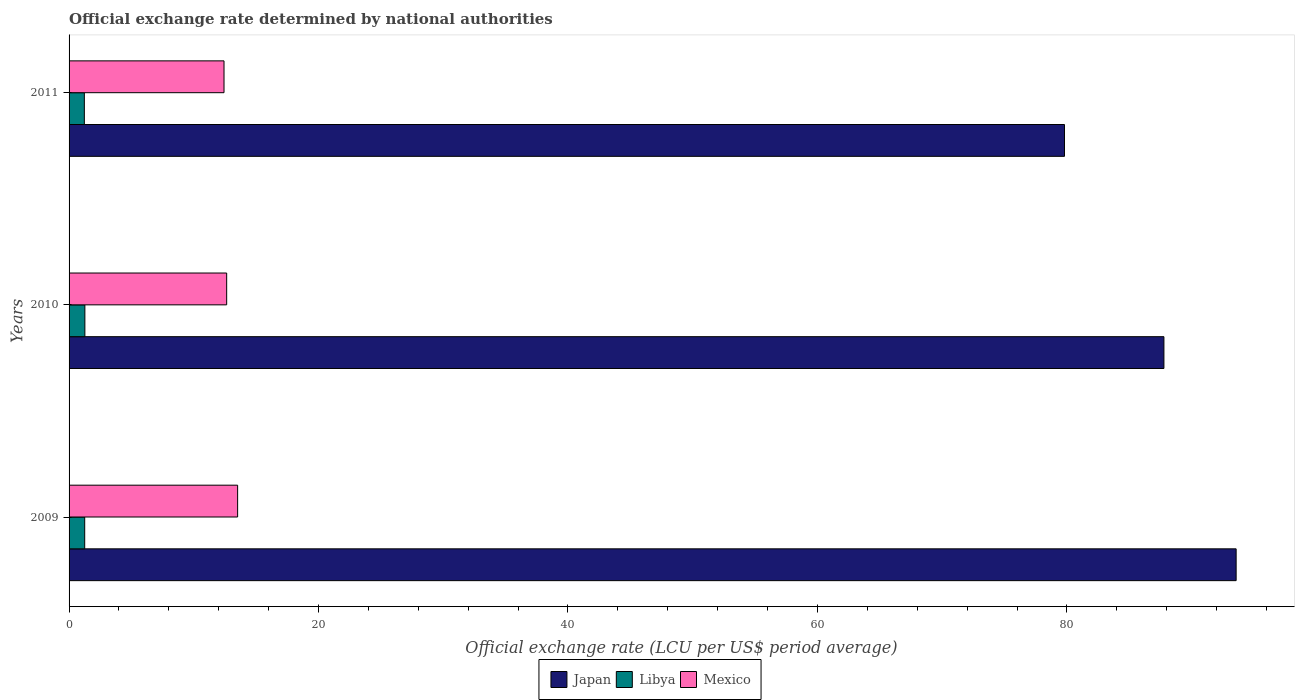Are the number of bars on each tick of the Y-axis equal?
Provide a short and direct response. Yes. How many bars are there on the 2nd tick from the top?
Provide a short and direct response. 3. How many bars are there on the 1st tick from the bottom?
Your response must be concise. 3. In how many cases, is the number of bars for a given year not equal to the number of legend labels?
Your answer should be very brief. 0. What is the official exchange rate in Libya in 2011?
Provide a succinct answer. 1.22. Across all years, what is the maximum official exchange rate in Libya?
Give a very brief answer. 1.27. Across all years, what is the minimum official exchange rate in Mexico?
Make the answer very short. 12.42. What is the total official exchange rate in Mexico in the graph?
Provide a succinct answer. 38.57. What is the difference between the official exchange rate in Mexico in 2010 and that in 2011?
Provide a short and direct response. 0.21. What is the difference between the official exchange rate in Libya in 2010 and the official exchange rate in Mexico in 2009?
Offer a very short reply. -12.25. What is the average official exchange rate in Mexico per year?
Give a very brief answer. 12.86. In the year 2010, what is the difference between the official exchange rate in Libya and official exchange rate in Japan?
Offer a very short reply. -86.51. In how many years, is the official exchange rate in Japan greater than 32 LCU?
Your answer should be very brief. 3. What is the ratio of the official exchange rate in Libya in 2009 to that in 2011?
Give a very brief answer. 1.02. What is the difference between the highest and the second highest official exchange rate in Libya?
Provide a succinct answer. 0.01. What is the difference between the highest and the lowest official exchange rate in Mexico?
Ensure brevity in your answer.  1.09. What does the 1st bar from the top in 2011 represents?
Keep it short and to the point. Mexico. What does the 3rd bar from the bottom in 2011 represents?
Give a very brief answer. Mexico. How many bars are there?
Provide a short and direct response. 9. What is the difference between two consecutive major ticks on the X-axis?
Offer a terse response. 20. Are the values on the major ticks of X-axis written in scientific E-notation?
Ensure brevity in your answer.  No. Does the graph contain any zero values?
Your answer should be compact. No. Does the graph contain grids?
Your answer should be compact. No. How are the legend labels stacked?
Keep it short and to the point. Horizontal. What is the title of the graph?
Offer a very short reply. Official exchange rate determined by national authorities. What is the label or title of the X-axis?
Make the answer very short. Official exchange rate (LCU per US$ period average). What is the Official exchange rate (LCU per US$ period average) in Japan in 2009?
Offer a very short reply. 93.57. What is the Official exchange rate (LCU per US$ period average) in Libya in 2009?
Keep it short and to the point. 1.25. What is the Official exchange rate (LCU per US$ period average) of Mexico in 2009?
Keep it short and to the point. 13.51. What is the Official exchange rate (LCU per US$ period average) of Japan in 2010?
Ensure brevity in your answer.  87.78. What is the Official exchange rate (LCU per US$ period average) of Libya in 2010?
Offer a very short reply. 1.27. What is the Official exchange rate (LCU per US$ period average) of Mexico in 2010?
Keep it short and to the point. 12.64. What is the Official exchange rate (LCU per US$ period average) in Japan in 2011?
Keep it short and to the point. 79.81. What is the Official exchange rate (LCU per US$ period average) of Libya in 2011?
Make the answer very short. 1.22. What is the Official exchange rate (LCU per US$ period average) in Mexico in 2011?
Keep it short and to the point. 12.42. Across all years, what is the maximum Official exchange rate (LCU per US$ period average) of Japan?
Your answer should be very brief. 93.57. Across all years, what is the maximum Official exchange rate (LCU per US$ period average) of Libya?
Offer a very short reply. 1.27. Across all years, what is the maximum Official exchange rate (LCU per US$ period average) of Mexico?
Offer a terse response. 13.51. Across all years, what is the minimum Official exchange rate (LCU per US$ period average) in Japan?
Your answer should be very brief. 79.81. Across all years, what is the minimum Official exchange rate (LCU per US$ period average) of Libya?
Provide a succinct answer. 1.22. Across all years, what is the minimum Official exchange rate (LCU per US$ period average) in Mexico?
Ensure brevity in your answer.  12.42. What is the total Official exchange rate (LCU per US$ period average) in Japan in the graph?
Your answer should be compact. 261.16. What is the total Official exchange rate (LCU per US$ period average) of Libya in the graph?
Make the answer very short. 3.74. What is the total Official exchange rate (LCU per US$ period average) in Mexico in the graph?
Make the answer very short. 38.57. What is the difference between the Official exchange rate (LCU per US$ period average) in Japan in 2009 and that in 2010?
Offer a terse response. 5.79. What is the difference between the Official exchange rate (LCU per US$ period average) of Libya in 2009 and that in 2010?
Provide a short and direct response. -0.01. What is the difference between the Official exchange rate (LCU per US$ period average) of Mexico in 2009 and that in 2010?
Ensure brevity in your answer.  0.88. What is the difference between the Official exchange rate (LCU per US$ period average) in Japan in 2009 and that in 2011?
Your answer should be very brief. 13.76. What is the difference between the Official exchange rate (LCU per US$ period average) of Libya in 2009 and that in 2011?
Your answer should be very brief. 0.03. What is the difference between the Official exchange rate (LCU per US$ period average) of Mexico in 2009 and that in 2011?
Your response must be concise. 1.09. What is the difference between the Official exchange rate (LCU per US$ period average) in Japan in 2010 and that in 2011?
Provide a succinct answer. 7.97. What is the difference between the Official exchange rate (LCU per US$ period average) of Libya in 2010 and that in 2011?
Your answer should be compact. 0.04. What is the difference between the Official exchange rate (LCU per US$ period average) of Mexico in 2010 and that in 2011?
Offer a terse response. 0.21. What is the difference between the Official exchange rate (LCU per US$ period average) of Japan in 2009 and the Official exchange rate (LCU per US$ period average) of Libya in 2010?
Give a very brief answer. 92.3. What is the difference between the Official exchange rate (LCU per US$ period average) of Japan in 2009 and the Official exchange rate (LCU per US$ period average) of Mexico in 2010?
Give a very brief answer. 80.93. What is the difference between the Official exchange rate (LCU per US$ period average) in Libya in 2009 and the Official exchange rate (LCU per US$ period average) in Mexico in 2010?
Ensure brevity in your answer.  -11.38. What is the difference between the Official exchange rate (LCU per US$ period average) of Japan in 2009 and the Official exchange rate (LCU per US$ period average) of Libya in 2011?
Ensure brevity in your answer.  92.35. What is the difference between the Official exchange rate (LCU per US$ period average) in Japan in 2009 and the Official exchange rate (LCU per US$ period average) in Mexico in 2011?
Make the answer very short. 81.15. What is the difference between the Official exchange rate (LCU per US$ period average) in Libya in 2009 and the Official exchange rate (LCU per US$ period average) in Mexico in 2011?
Provide a short and direct response. -11.17. What is the difference between the Official exchange rate (LCU per US$ period average) in Japan in 2010 and the Official exchange rate (LCU per US$ period average) in Libya in 2011?
Your response must be concise. 86.56. What is the difference between the Official exchange rate (LCU per US$ period average) in Japan in 2010 and the Official exchange rate (LCU per US$ period average) in Mexico in 2011?
Your answer should be very brief. 75.36. What is the difference between the Official exchange rate (LCU per US$ period average) in Libya in 2010 and the Official exchange rate (LCU per US$ period average) in Mexico in 2011?
Make the answer very short. -11.16. What is the average Official exchange rate (LCU per US$ period average) of Japan per year?
Make the answer very short. 87.05. What is the average Official exchange rate (LCU per US$ period average) in Libya per year?
Your answer should be compact. 1.25. What is the average Official exchange rate (LCU per US$ period average) of Mexico per year?
Make the answer very short. 12.86. In the year 2009, what is the difference between the Official exchange rate (LCU per US$ period average) in Japan and Official exchange rate (LCU per US$ period average) in Libya?
Keep it short and to the point. 92.32. In the year 2009, what is the difference between the Official exchange rate (LCU per US$ period average) in Japan and Official exchange rate (LCU per US$ period average) in Mexico?
Make the answer very short. 80.06. In the year 2009, what is the difference between the Official exchange rate (LCU per US$ period average) in Libya and Official exchange rate (LCU per US$ period average) in Mexico?
Make the answer very short. -12.26. In the year 2010, what is the difference between the Official exchange rate (LCU per US$ period average) of Japan and Official exchange rate (LCU per US$ period average) of Libya?
Provide a succinct answer. 86.51. In the year 2010, what is the difference between the Official exchange rate (LCU per US$ period average) of Japan and Official exchange rate (LCU per US$ period average) of Mexico?
Your response must be concise. 75.14. In the year 2010, what is the difference between the Official exchange rate (LCU per US$ period average) of Libya and Official exchange rate (LCU per US$ period average) of Mexico?
Your answer should be compact. -11.37. In the year 2011, what is the difference between the Official exchange rate (LCU per US$ period average) of Japan and Official exchange rate (LCU per US$ period average) of Libya?
Your answer should be compact. 78.58. In the year 2011, what is the difference between the Official exchange rate (LCU per US$ period average) in Japan and Official exchange rate (LCU per US$ period average) in Mexico?
Make the answer very short. 67.38. In the year 2011, what is the difference between the Official exchange rate (LCU per US$ period average) of Libya and Official exchange rate (LCU per US$ period average) of Mexico?
Offer a terse response. -11.2. What is the ratio of the Official exchange rate (LCU per US$ period average) of Japan in 2009 to that in 2010?
Offer a terse response. 1.07. What is the ratio of the Official exchange rate (LCU per US$ period average) in Libya in 2009 to that in 2010?
Your response must be concise. 0.99. What is the ratio of the Official exchange rate (LCU per US$ period average) in Mexico in 2009 to that in 2010?
Offer a terse response. 1.07. What is the ratio of the Official exchange rate (LCU per US$ period average) in Japan in 2009 to that in 2011?
Your answer should be compact. 1.17. What is the ratio of the Official exchange rate (LCU per US$ period average) of Libya in 2009 to that in 2011?
Give a very brief answer. 1.02. What is the ratio of the Official exchange rate (LCU per US$ period average) of Mexico in 2009 to that in 2011?
Your answer should be very brief. 1.09. What is the ratio of the Official exchange rate (LCU per US$ period average) in Japan in 2010 to that in 2011?
Provide a short and direct response. 1.1. What is the ratio of the Official exchange rate (LCU per US$ period average) in Libya in 2010 to that in 2011?
Keep it short and to the point. 1.03. What is the ratio of the Official exchange rate (LCU per US$ period average) in Mexico in 2010 to that in 2011?
Offer a terse response. 1.02. What is the difference between the highest and the second highest Official exchange rate (LCU per US$ period average) in Japan?
Your response must be concise. 5.79. What is the difference between the highest and the second highest Official exchange rate (LCU per US$ period average) in Libya?
Your answer should be very brief. 0.01. What is the difference between the highest and the second highest Official exchange rate (LCU per US$ period average) in Mexico?
Ensure brevity in your answer.  0.88. What is the difference between the highest and the lowest Official exchange rate (LCU per US$ period average) in Japan?
Offer a very short reply. 13.76. What is the difference between the highest and the lowest Official exchange rate (LCU per US$ period average) in Libya?
Offer a very short reply. 0.04. What is the difference between the highest and the lowest Official exchange rate (LCU per US$ period average) of Mexico?
Provide a succinct answer. 1.09. 